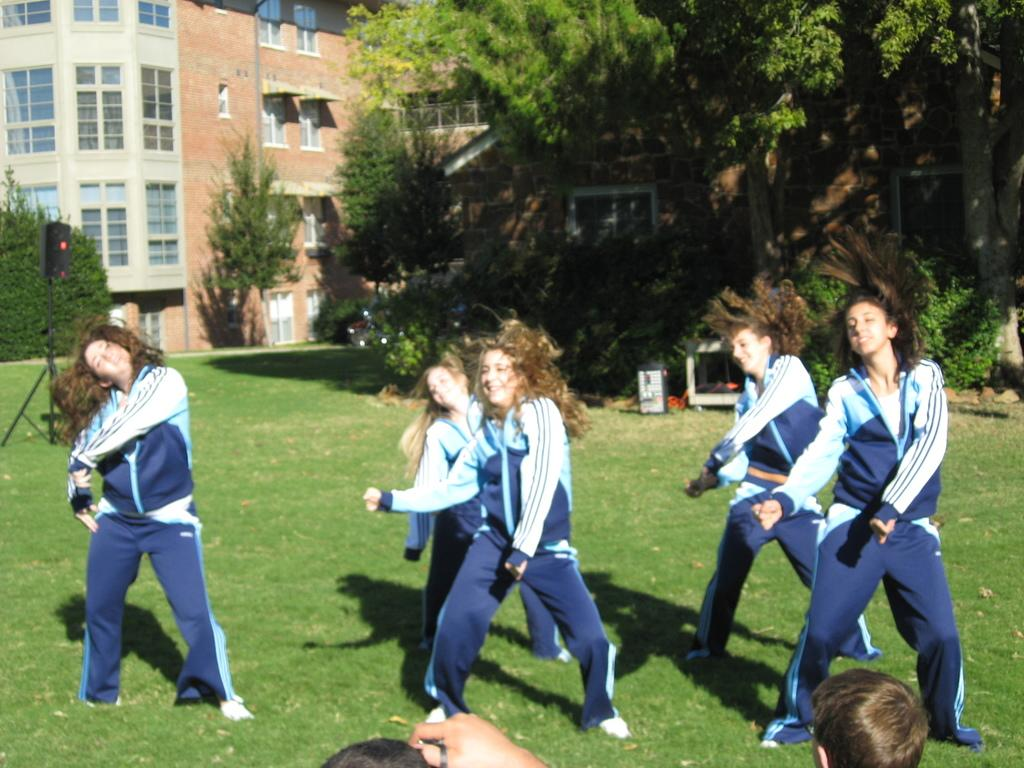What is happening in the image involving a group of people? There is a group of women in the image, and they are dancing. Where is the dancing taking place? The dancing is taking place in a garden. What can be seen in the background of the image? There are trees visible in the image, and behind the trees, there is a huge building. Can you describe the vegetation in the image? The vegetation in the image includes trees, which are located in the garden where the women are dancing. What type of lamp is being used by the women while they are dancing? There is no lamp present in the image; the women are dancing in a garden. 